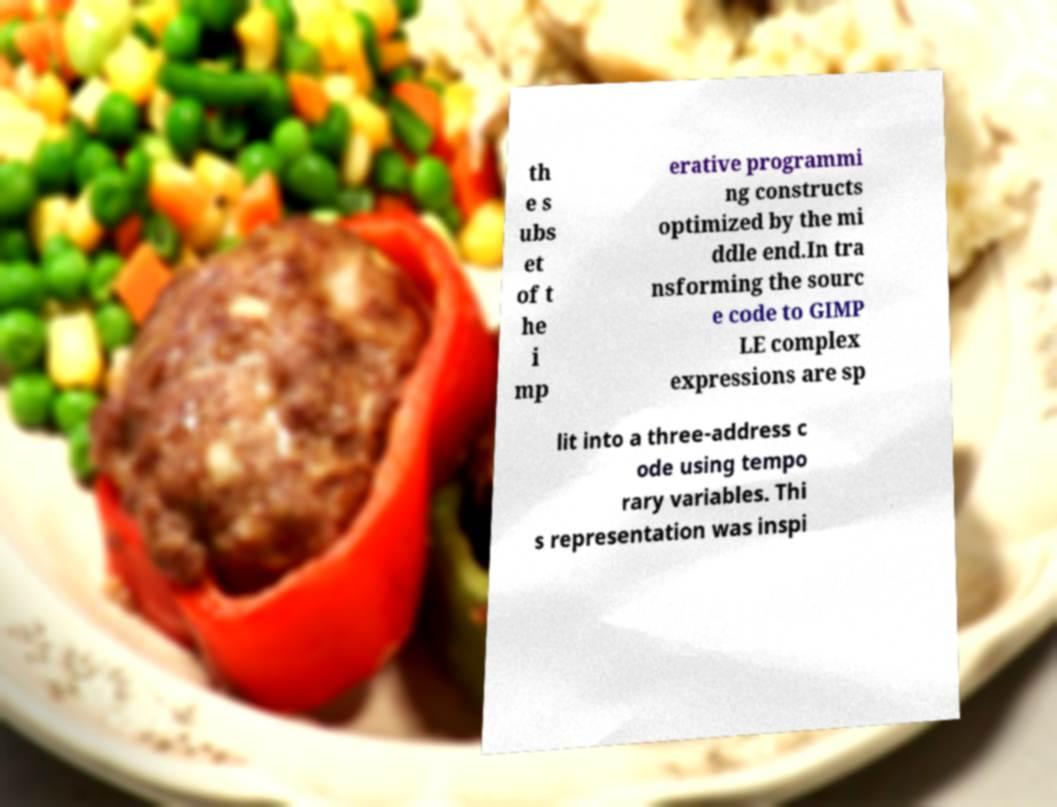Please read and relay the text visible in this image. What does it say? th e s ubs et of t he i mp erative programmi ng constructs optimized by the mi ddle end.In tra nsforming the sourc e code to GIMP LE complex expressions are sp lit into a three-address c ode using tempo rary variables. Thi s representation was inspi 